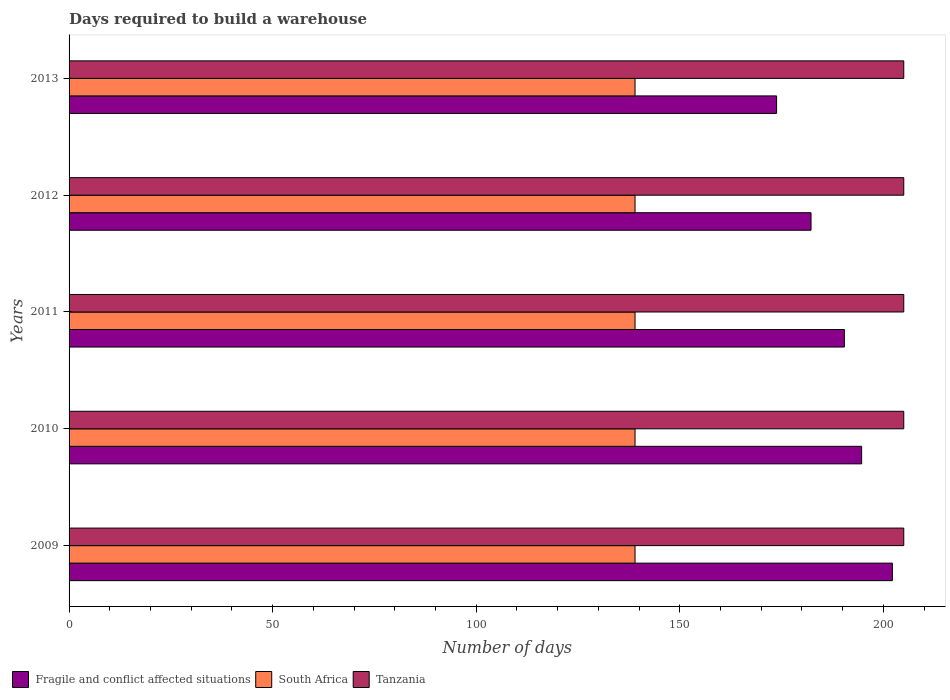How many groups of bars are there?
Offer a terse response. 5. Are the number of bars on each tick of the Y-axis equal?
Your answer should be very brief. Yes. What is the label of the 3rd group of bars from the top?
Offer a very short reply. 2011. In how many cases, is the number of bars for a given year not equal to the number of legend labels?
Offer a terse response. 0. What is the days required to build a warehouse in in South Africa in 2010?
Your answer should be compact. 139. Across all years, what is the maximum days required to build a warehouse in in Tanzania?
Give a very brief answer. 205. Across all years, what is the minimum days required to build a warehouse in in Tanzania?
Your answer should be compact. 205. In which year was the days required to build a warehouse in in Tanzania maximum?
Offer a very short reply. 2009. What is the total days required to build a warehouse in in Fragile and conflict affected situations in the graph?
Your response must be concise. 943.27. What is the difference between the days required to build a warehouse in in Fragile and conflict affected situations in 2009 and that in 2011?
Your answer should be compact. 11.79. What is the difference between the days required to build a warehouse in in Tanzania in 2010 and the days required to build a warehouse in in South Africa in 2013?
Provide a short and direct response. 66. What is the average days required to build a warehouse in in Fragile and conflict affected situations per year?
Ensure brevity in your answer.  188.65. In the year 2009, what is the difference between the days required to build a warehouse in in Tanzania and days required to build a warehouse in in South Africa?
Keep it short and to the point. 66. What is the ratio of the days required to build a warehouse in in Fragile and conflict affected situations in 2011 to that in 2013?
Provide a short and direct response. 1.1. Is the days required to build a warehouse in in South Africa in 2012 less than that in 2013?
Keep it short and to the point. No. What is the difference between the highest and the second highest days required to build a warehouse in in Fragile and conflict affected situations?
Your answer should be very brief. 7.55. In how many years, is the days required to build a warehouse in in Fragile and conflict affected situations greater than the average days required to build a warehouse in in Fragile and conflict affected situations taken over all years?
Provide a succinct answer. 3. Is the sum of the days required to build a warehouse in in Fragile and conflict affected situations in 2012 and 2013 greater than the maximum days required to build a warehouse in in South Africa across all years?
Keep it short and to the point. Yes. What does the 1st bar from the top in 2012 represents?
Your response must be concise. Tanzania. What does the 3rd bar from the bottom in 2012 represents?
Your answer should be compact. Tanzania. How many bars are there?
Offer a very short reply. 15. How many years are there in the graph?
Give a very brief answer. 5. Does the graph contain grids?
Give a very brief answer. No. Where does the legend appear in the graph?
Keep it short and to the point. Bottom left. What is the title of the graph?
Offer a very short reply. Days required to build a warehouse. What is the label or title of the X-axis?
Keep it short and to the point. Number of days. What is the Number of days in Fragile and conflict affected situations in 2009?
Provide a short and direct response. 202.21. What is the Number of days of South Africa in 2009?
Keep it short and to the point. 139. What is the Number of days in Tanzania in 2009?
Give a very brief answer. 205. What is the Number of days of Fragile and conflict affected situations in 2010?
Your answer should be compact. 194.66. What is the Number of days of South Africa in 2010?
Provide a short and direct response. 139. What is the Number of days of Tanzania in 2010?
Offer a very short reply. 205. What is the Number of days in Fragile and conflict affected situations in 2011?
Ensure brevity in your answer.  190.41. What is the Number of days of South Africa in 2011?
Give a very brief answer. 139. What is the Number of days of Tanzania in 2011?
Provide a succinct answer. 205. What is the Number of days in Fragile and conflict affected situations in 2012?
Offer a very short reply. 182.23. What is the Number of days in South Africa in 2012?
Make the answer very short. 139. What is the Number of days of Tanzania in 2012?
Your answer should be compact. 205. What is the Number of days in Fragile and conflict affected situations in 2013?
Your response must be concise. 173.77. What is the Number of days of South Africa in 2013?
Make the answer very short. 139. What is the Number of days in Tanzania in 2013?
Your response must be concise. 205. Across all years, what is the maximum Number of days in Fragile and conflict affected situations?
Provide a short and direct response. 202.21. Across all years, what is the maximum Number of days in South Africa?
Your answer should be compact. 139. Across all years, what is the maximum Number of days in Tanzania?
Your response must be concise. 205. Across all years, what is the minimum Number of days in Fragile and conflict affected situations?
Offer a very short reply. 173.77. Across all years, what is the minimum Number of days of South Africa?
Your answer should be very brief. 139. Across all years, what is the minimum Number of days in Tanzania?
Your answer should be compact. 205. What is the total Number of days in Fragile and conflict affected situations in the graph?
Offer a very short reply. 943.27. What is the total Number of days in South Africa in the graph?
Provide a short and direct response. 695. What is the total Number of days of Tanzania in the graph?
Give a very brief answer. 1025. What is the difference between the Number of days of Fragile and conflict affected situations in 2009 and that in 2010?
Your answer should be compact. 7.55. What is the difference between the Number of days of Tanzania in 2009 and that in 2010?
Your answer should be compact. 0. What is the difference between the Number of days in Fragile and conflict affected situations in 2009 and that in 2011?
Your answer should be compact. 11.79. What is the difference between the Number of days of South Africa in 2009 and that in 2011?
Your answer should be very brief. 0. What is the difference between the Number of days of Tanzania in 2009 and that in 2011?
Provide a short and direct response. 0. What is the difference between the Number of days of Fragile and conflict affected situations in 2009 and that in 2012?
Ensure brevity in your answer.  19.98. What is the difference between the Number of days in South Africa in 2009 and that in 2012?
Provide a succinct answer. 0. What is the difference between the Number of days in Fragile and conflict affected situations in 2009 and that in 2013?
Keep it short and to the point. 28.44. What is the difference between the Number of days of South Africa in 2009 and that in 2013?
Offer a terse response. 0. What is the difference between the Number of days of Tanzania in 2009 and that in 2013?
Give a very brief answer. 0. What is the difference between the Number of days of Fragile and conflict affected situations in 2010 and that in 2011?
Offer a very short reply. 4.24. What is the difference between the Number of days of South Africa in 2010 and that in 2011?
Your answer should be very brief. 0. What is the difference between the Number of days of Tanzania in 2010 and that in 2011?
Give a very brief answer. 0. What is the difference between the Number of days of Fragile and conflict affected situations in 2010 and that in 2012?
Ensure brevity in your answer.  12.43. What is the difference between the Number of days of South Africa in 2010 and that in 2012?
Keep it short and to the point. 0. What is the difference between the Number of days in Fragile and conflict affected situations in 2010 and that in 2013?
Your answer should be very brief. 20.89. What is the difference between the Number of days in South Africa in 2010 and that in 2013?
Keep it short and to the point. 0. What is the difference between the Number of days of Fragile and conflict affected situations in 2011 and that in 2012?
Make the answer very short. 8.19. What is the difference between the Number of days in South Africa in 2011 and that in 2012?
Offer a terse response. 0. What is the difference between the Number of days in Fragile and conflict affected situations in 2011 and that in 2013?
Keep it short and to the point. 16.65. What is the difference between the Number of days in Tanzania in 2011 and that in 2013?
Your answer should be very brief. 0. What is the difference between the Number of days of Fragile and conflict affected situations in 2012 and that in 2013?
Your answer should be compact. 8.46. What is the difference between the Number of days of South Africa in 2012 and that in 2013?
Your answer should be very brief. 0. What is the difference between the Number of days in Tanzania in 2012 and that in 2013?
Keep it short and to the point. 0. What is the difference between the Number of days of Fragile and conflict affected situations in 2009 and the Number of days of South Africa in 2010?
Your answer should be very brief. 63.21. What is the difference between the Number of days of Fragile and conflict affected situations in 2009 and the Number of days of Tanzania in 2010?
Provide a short and direct response. -2.79. What is the difference between the Number of days of South Africa in 2009 and the Number of days of Tanzania in 2010?
Ensure brevity in your answer.  -66. What is the difference between the Number of days of Fragile and conflict affected situations in 2009 and the Number of days of South Africa in 2011?
Your response must be concise. 63.21. What is the difference between the Number of days of Fragile and conflict affected situations in 2009 and the Number of days of Tanzania in 2011?
Your answer should be very brief. -2.79. What is the difference between the Number of days in South Africa in 2009 and the Number of days in Tanzania in 2011?
Make the answer very short. -66. What is the difference between the Number of days of Fragile and conflict affected situations in 2009 and the Number of days of South Africa in 2012?
Offer a very short reply. 63.21. What is the difference between the Number of days in Fragile and conflict affected situations in 2009 and the Number of days in Tanzania in 2012?
Ensure brevity in your answer.  -2.79. What is the difference between the Number of days in South Africa in 2009 and the Number of days in Tanzania in 2012?
Ensure brevity in your answer.  -66. What is the difference between the Number of days of Fragile and conflict affected situations in 2009 and the Number of days of South Africa in 2013?
Make the answer very short. 63.21. What is the difference between the Number of days in Fragile and conflict affected situations in 2009 and the Number of days in Tanzania in 2013?
Your answer should be compact. -2.79. What is the difference between the Number of days of South Africa in 2009 and the Number of days of Tanzania in 2013?
Your answer should be compact. -66. What is the difference between the Number of days in Fragile and conflict affected situations in 2010 and the Number of days in South Africa in 2011?
Offer a very short reply. 55.66. What is the difference between the Number of days of Fragile and conflict affected situations in 2010 and the Number of days of Tanzania in 2011?
Make the answer very short. -10.34. What is the difference between the Number of days in South Africa in 2010 and the Number of days in Tanzania in 2011?
Ensure brevity in your answer.  -66. What is the difference between the Number of days in Fragile and conflict affected situations in 2010 and the Number of days in South Africa in 2012?
Provide a short and direct response. 55.66. What is the difference between the Number of days of Fragile and conflict affected situations in 2010 and the Number of days of Tanzania in 2012?
Offer a very short reply. -10.34. What is the difference between the Number of days of South Africa in 2010 and the Number of days of Tanzania in 2012?
Your response must be concise. -66. What is the difference between the Number of days of Fragile and conflict affected situations in 2010 and the Number of days of South Africa in 2013?
Your answer should be very brief. 55.66. What is the difference between the Number of days of Fragile and conflict affected situations in 2010 and the Number of days of Tanzania in 2013?
Provide a succinct answer. -10.34. What is the difference between the Number of days of South Africa in 2010 and the Number of days of Tanzania in 2013?
Ensure brevity in your answer.  -66. What is the difference between the Number of days of Fragile and conflict affected situations in 2011 and the Number of days of South Africa in 2012?
Offer a terse response. 51.41. What is the difference between the Number of days of Fragile and conflict affected situations in 2011 and the Number of days of Tanzania in 2012?
Provide a succinct answer. -14.59. What is the difference between the Number of days in South Africa in 2011 and the Number of days in Tanzania in 2012?
Offer a terse response. -66. What is the difference between the Number of days in Fragile and conflict affected situations in 2011 and the Number of days in South Africa in 2013?
Offer a terse response. 51.41. What is the difference between the Number of days of Fragile and conflict affected situations in 2011 and the Number of days of Tanzania in 2013?
Provide a short and direct response. -14.59. What is the difference between the Number of days of South Africa in 2011 and the Number of days of Tanzania in 2013?
Give a very brief answer. -66. What is the difference between the Number of days in Fragile and conflict affected situations in 2012 and the Number of days in South Africa in 2013?
Provide a short and direct response. 43.23. What is the difference between the Number of days in Fragile and conflict affected situations in 2012 and the Number of days in Tanzania in 2013?
Provide a succinct answer. -22.77. What is the difference between the Number of days in South Africa in 2012 and the Number of days in Tanzania in 2013?
Provide a short and direct response. -66. What is the average Number of days of Fragile and conflict affected situations per year?
Keep it short and to the point. 188.65. What is the average Number of days in South Africa per year?
Your answer should be compact. 139. What is the average Number of days in Tanzania per year?
Provide a short and direct response. 205. In the year 2009, what is the difference between the Number of days in Fragile and conflict affected situations and Number of days in South Africa?
Keep it short and to the point. 63.21. In the year 2009, what is the difference between the Number of days in Fragile and conflict affected situations and Number of days in Tanzania?
Provide a short and direct response. -2.79. In the year 2009, what is the difference between the Number of days in South Africa and Number of days in Tanzania?
Give a very brief answer. -66. In the year 2010, what is the difference between the Number of days in Fragile and conflict affected situations and Number of days in South Africa?
Give a very brief answer. 55.66. In the year 2010, what is the difference between the Number of days of Fragile and conflict affected situations and Number of days of Tanzania?
Provide a succinct answer. -10.34. In the year 2010, what is the difference between the Number of days in South Africa and Number of days in Tanzania?
Keep it short and to the point. -66. In the year 2011, what is the difference between the Number of days of Fragile and conflict affected situations and Number of days of South Africa?
Ensure brevity in your answer.  51.41. In the year 2011, what is the difference between the Number of days in Fragile and conflict affected situations and Number of days in Tanzania?
Your answer should be very brief. -14.59. In the year 2011, what is the difference between the Number of days of South Africa and Number of days of Tanzania?
Give a very brief answer. -66. In the year 2012, what is the difference between the Number of days in Fragile and conflict affected situations and Number of days in South Africa?
Give a very brief answer. 43.23. In the year 2012, what is the difference between the Number of days of Fragile and conflict affected situations and Number of days of Tanzania?
Give a very brief answer. -22.77. In the year 2012, what is the difference between the Number of days of South Africa and Number of days of Tanzania?
Make the answer very short. -66. In the year 2013, what is the difference between the Number of days in Fragile and conflict affected situations and Number of days in South Africa?
Ensure brevity in your answer.  34.77. In the year 2013, what is the difference between the Number of days of Fragile and conflict affected situations and Number of days of Tanzania?
Keep it short and to the point. -31.23. In the year 2013, what is the difference between the Number of days of South Africa and Number of days of Tanzania?
Your response must be concise. -66. What is the ratio of the Number of days of Fragile and conflict affected situations in 2009 to that in 2010?
Your answer should be very brief. 1.04. What is the ratio of the Number of days of Tanzania in 2009 to that in 2010?
Provide a short and direct response. 1. What is the ratio of the Number of days in Fragile and conflict affected situations in 2009 to that in 2011?
Provide a short and direct response. 1.06. What is the ratio of the Number of days in South Africa in 2009 to that in 2011?
Your answer should be compact. 1. What is the ratio of the Number of days in Fragile and conflict affected situations in 2009 to that in 2012?
Make the answer very short. 1.11. What is the ratio of the Number of days of South Africa in 2009 to that in 2012?
Offer a very short reply. 1. What is the ratio of the Number of days of Fragile and conflict affected situations in 2009 to that in 2013?
Give a very brief answer. 1.16. What is the ratio of the Number of days of South Africa in 2009 to that in 2013?
Give a very brief answer. 1. What is the ratio of the Number of days in Tanzania in 2009 to that in 2013?
Provide a short and direct response. 1. What is the ratio of the Number of days of Fragile and conflict affected situations in 2010 to that in 2011?
Provide a short and direct response. 1.02. What is the ratio of the Number of days of South Africa in 2010 to that in 2011?
Offer a very short reply. 1. What is the ratio of the Number of days in Tanzania in 2010 to that in 2011?
Make the answer very short. 1. What is the ratio of the Number of days of Fragile and conflict affected situations in 2010 to that in 2012?
Keep it short and to the point. 1.07. What is the ratio of the Number of days in Fragile and conflict affected situations in 2010 to that in 2013?
Your response must be concise. 1.12. What is the ratio of the Number of days in South Africa in 2010 to that in 2013?
Make the answer very short. 1. What is the ratio of the Number of days of Fragile and conflict affected situations in 2011 to that in 2012?
Give a very brief answer. 1.04. What is the ratio of the Number of days of South Africa in 2011 to that in 2012?
Provide a succinct answer. 1. What is the ratio of the Number of days of Tanzania in 2011 to that in 2012?
Give a very brief answer. 1. What is the ratio of the Number of days in Fragile and conflict affected situations in 2011 to that in 2013?
Offer a terse response. 1.1. What is the ratio of the Number of days in South Africa in 2011 to that in 2013?
Offer a very short reply. 1. What is the ratio of the Number of days of Tanzania in 2011 to that in 2013?
Your answer should be very brief. 1. What is the ratio of the Number of days in Fragile and conflict affected situations in 2012 to that in 2013?
Offer a very short reply. 1.05. What is the difference between the highest and the second highest Number of days in Fragile and conflict affected situations?
Your response must be concise. 7.55. What is the difference between the highest and the second highest Number of days in Tanzania?
Offer a terse response. 0. What is the difference between the highest and the lowest Number of days in Fragile and conflict affected situations?
Provide a succinct answer. 28.44. What is the difference between the highest and the lowest Number of days in South Africa?
Give a very brief answer. 0. What is the difference between the highest and the lowest Number of days of Tanzania?
Your answer should be compact. 0. 